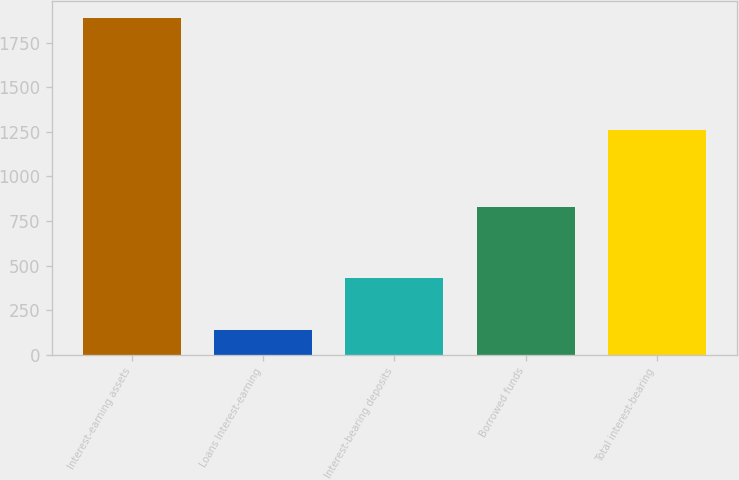<chart> <loc_0><loc_0><loc_500><loc_500><bar_chart><fcel>Interest-earning assets<fcel>Loans Interest-earning<fcel>Interest-bearing deposits<fcel>Borrowed funds<fcel>Total interest-bearing<nl><fcel>1889<fcel>136<fcel>430<fcel>831<fcel>1261<nl></chart> 